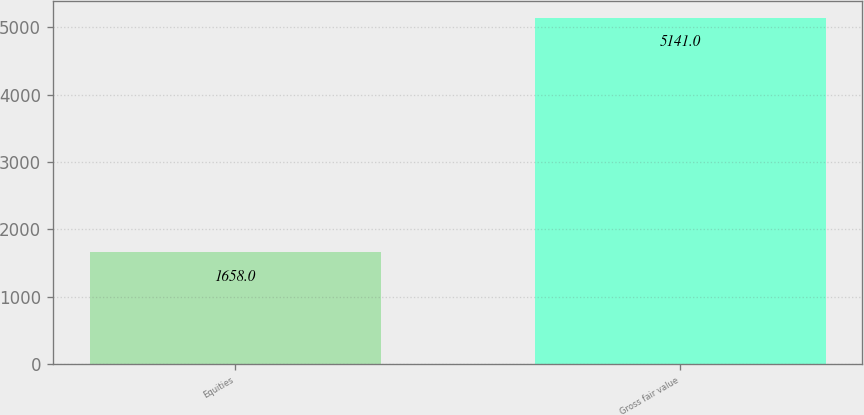<chart> <loc_0><loc_0><loc_500><loc_500><bar_chart><fcel>Equities<fcel>Gross fair value<nl><fcel>1658<fcel>5141<nl></chart> 